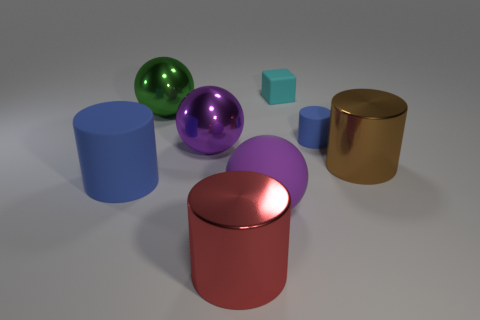The small cylinder that is made of the same material as the cyan object is what color?
Provide a succinct answer. Blue. Is the number of small cyan matte cubes that are in front of the red metal object the same as the number of small cyan shiny spheres?
Your answer should be very brief. Yes. Is the size of the blue thing right of the cyan rubber thing the same as the big blue rubber cylinder?
Your answer should be compact. No. There is a matte sphere that is the same size as the red shiny thing; what color is it?
Make the answer very short. Purple. Is there a object to the right of the big shiny thing that is right of the cube behind the large brown metal thing?
Your response must be concise. No. What is the material of the blue thing that is to the left of the small rubber block?
Offer a very short reply. Rubber. Do the large purple matte thing and the big metal thing that is in front of the large purple rubber thing have the same shape?
Provide a short and direct response. No. Are there the same number of big purple rubber balls to the right of the small cyan matte cube and tiny cyan things right of the large brown thing?
Offer a terse response. Yes. How many other things are there of the same material as the cyan cube?
Provide a succinct answer. 3. What number of shiny objects are large red cylinders or big purple spheres?
Keep it short and to the point. 2. 